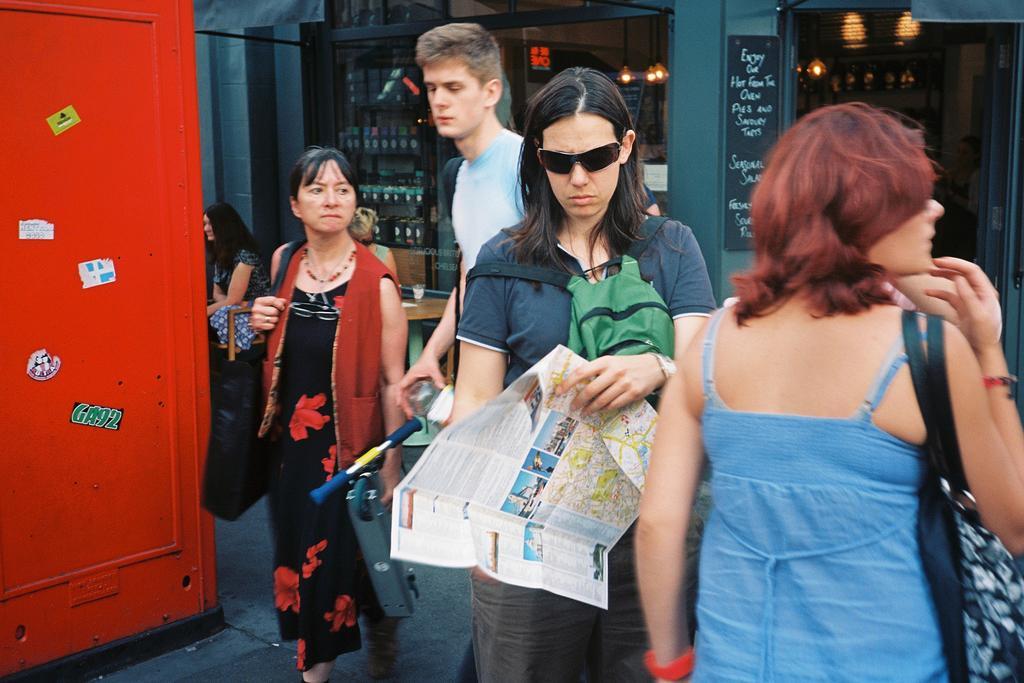How would you summarize this image in a sentence or two? In the foreground of the picture we can see people. On the left there is a red color object. In the background we can see people, racks, bottles, board, light, wall, pillar and various objects. 